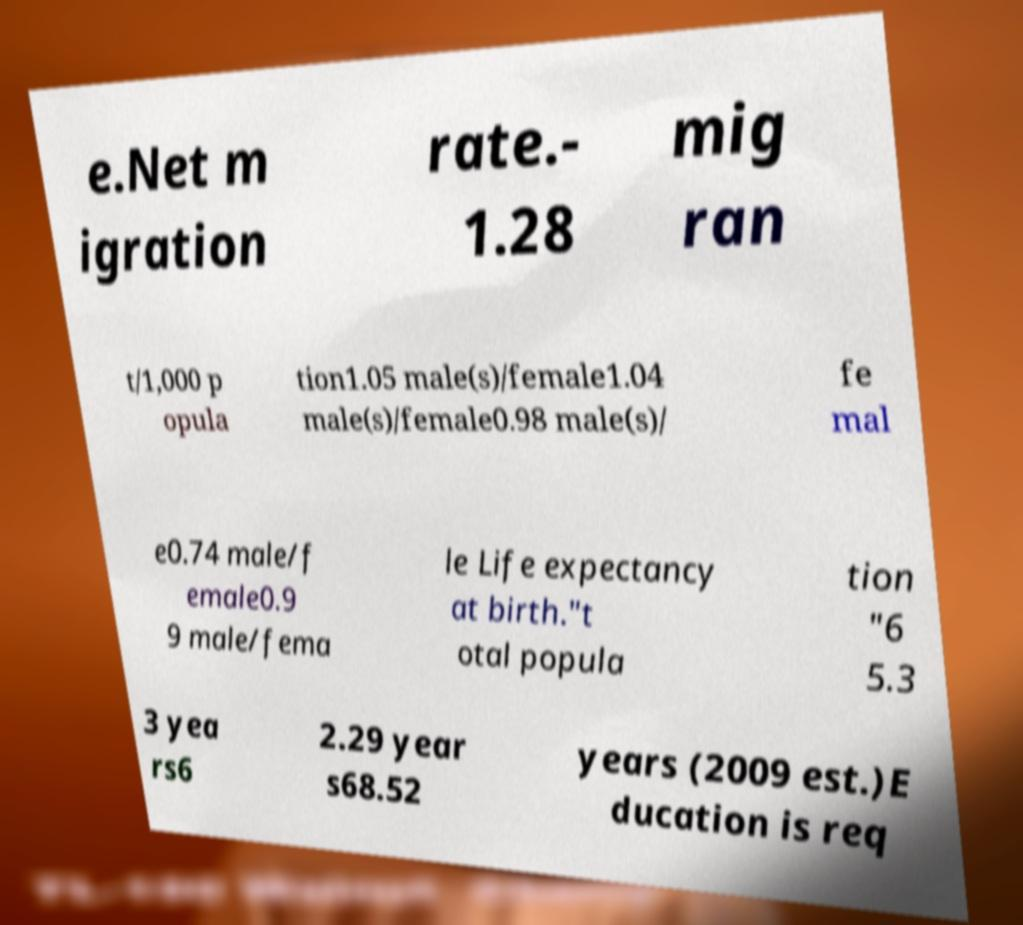Could you extract and type out the text from this image? e.Net m igration rate.- 1.28 mig ran t/1,000 p opula tion1.05 male(s)/female1.04 male(s)/female0.98 male(s)/ fe mal e0.74 male/f emale0.9 9 male/fema le Life expectancy at birth."t otal popula tion "6 5.3 3 yea rs6 2.29 year s68.52 years (2009 est.)E ducation is req 